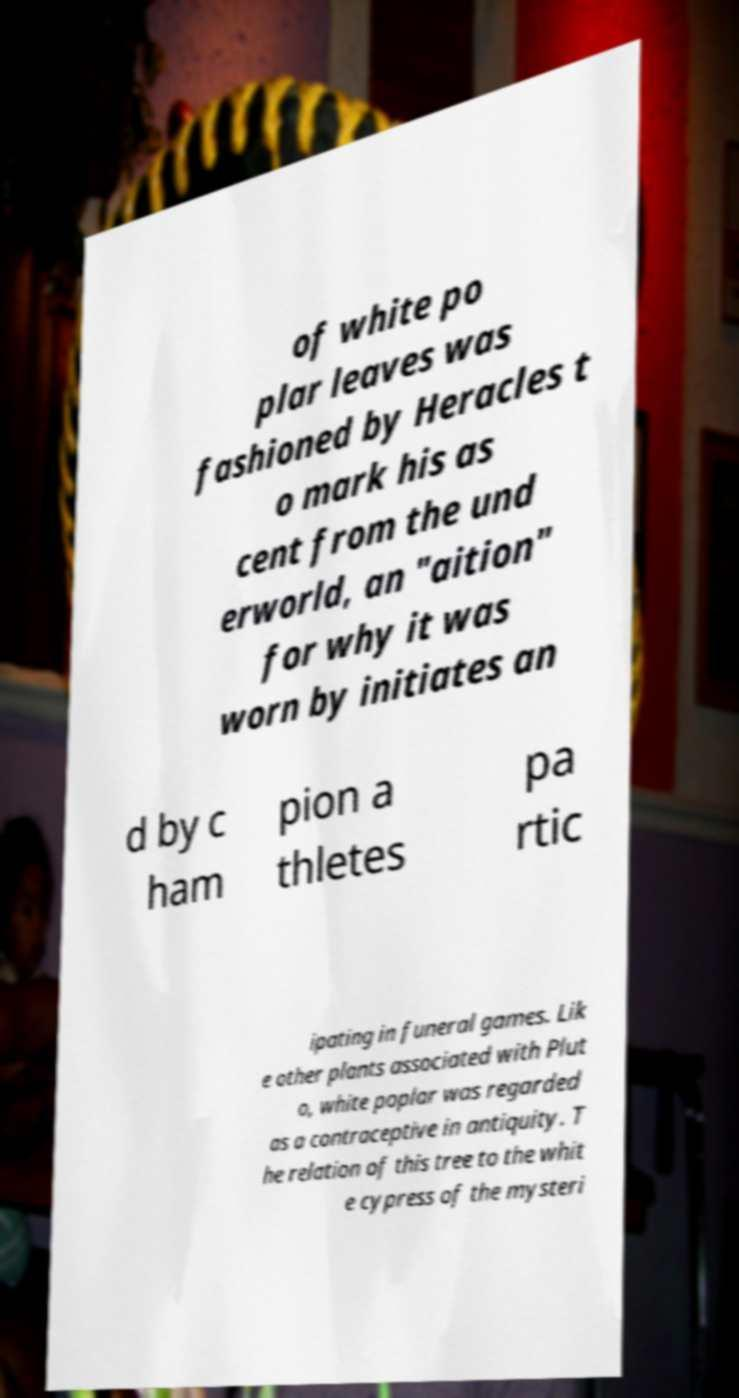Could you extract and type out the text from this image? of white po plar leaves was fashioned by Heracles t o mark his as cent from the und erworld, an "aition" for why it was worn by initiates an d by c ham pion a thletes pa rtic ipating in funeral games. Lik e other plants associated with Plut o, white poplar was regarded as a contraceptive in antiquity. T he relation of this tree to the whit e cypress of the mysteri 